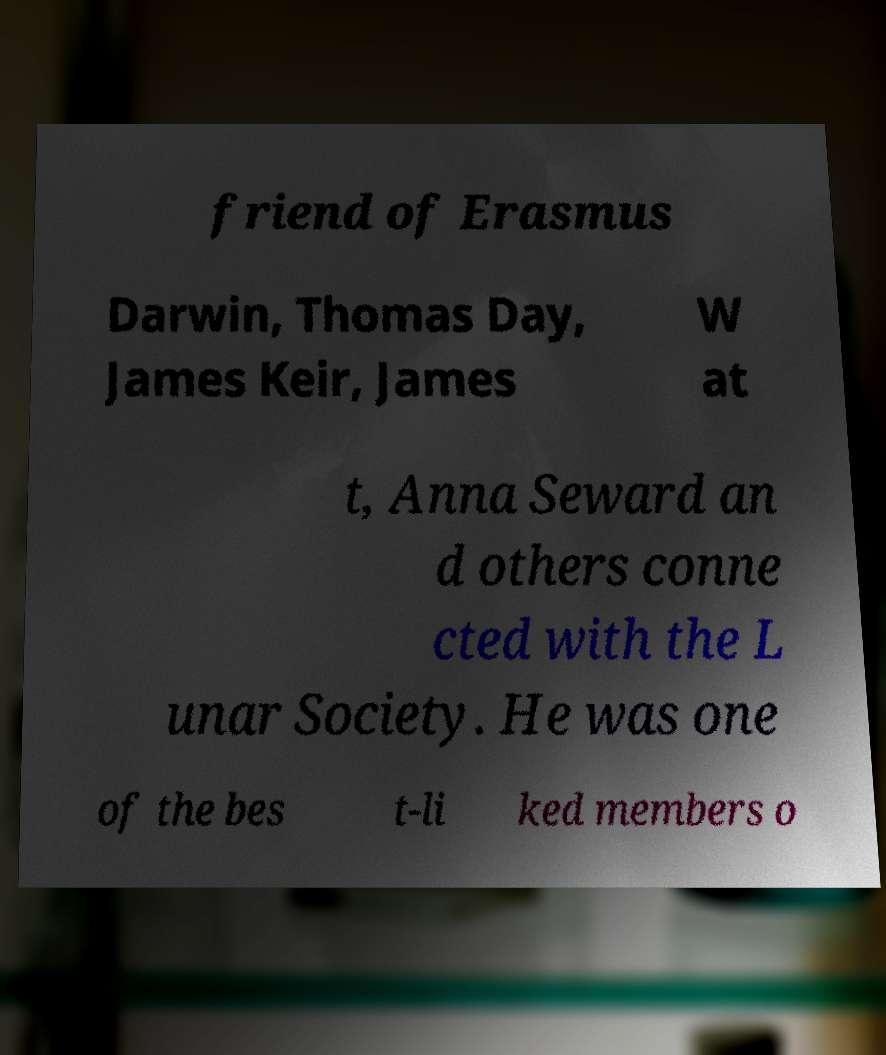Can you read and provide the text displayed in the image?This photo seems to have some interesting text. Can you extract and type it out for me? friend of Erasmus Darwin, Thomas Day, James Keir, James W at t, Anna Seward an d others conne cted with the L unar Society. He was one of the bes t-li ked members o 